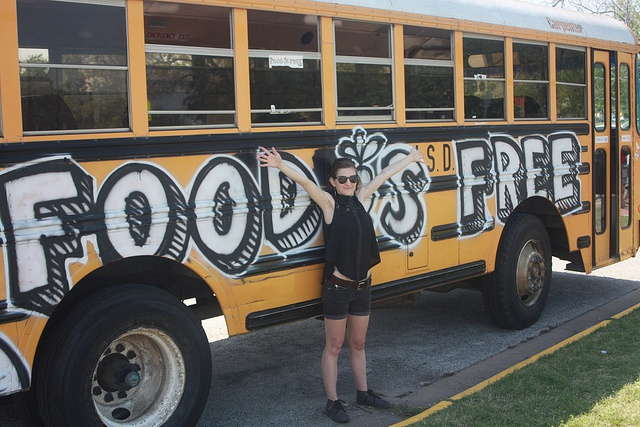Describe the objects in this image and their specific colors. I can see bus in tan, black, gray, and lightgray tones, people in tan, black, gray, and darkgray tones, and chair in tan, black, gray, and darkgray tones in this image. 